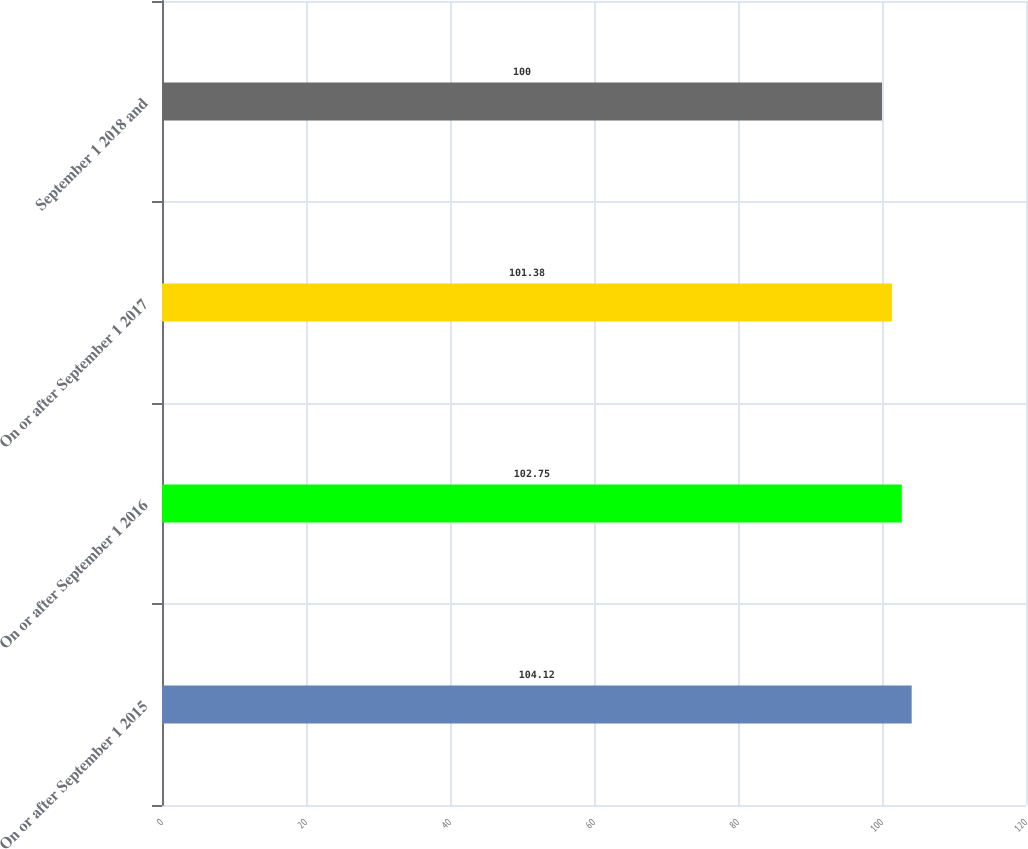Convert chart to OTSL. <chart><loc_0><loc_0><loc_500><loc_500><bar_chart><fcel>On or after September 1 2015<fcel>On or after September 1 2016<fcel>On or after September 1 2017<fcel>September 1 2018 and<nl><fcel>104.12<fcel>102.75<fcel>101.38<fcel>100<nl></chart> 